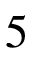<formula> <loc_0><loc_0><loc_500><loc_500>5</formula> 